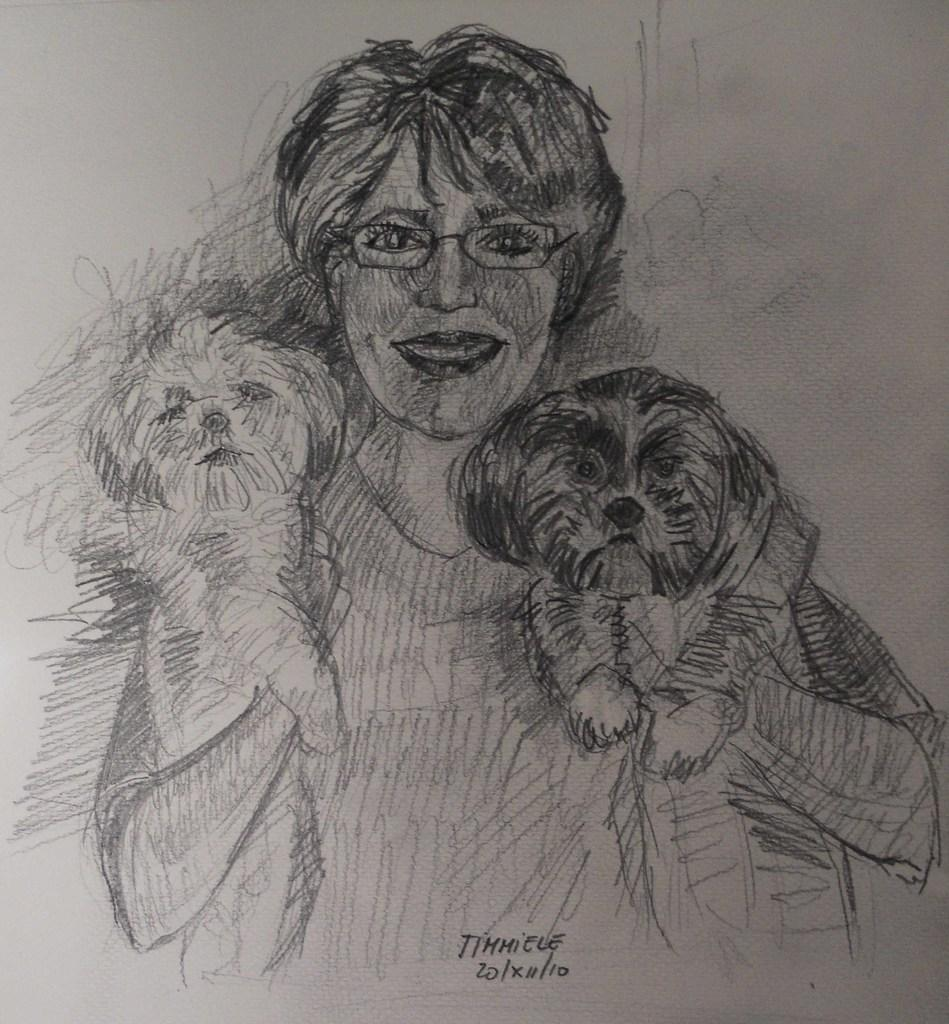What is depicted on the paper in the image? The paper contains a sketch of a person and a sketch of a dog. Is there any text on the paper? Yes, there is text at the bottom of the paper. How much money is inside the tent in the image? There is no tent or money present in the image; it only features a paper with sketches and text. 